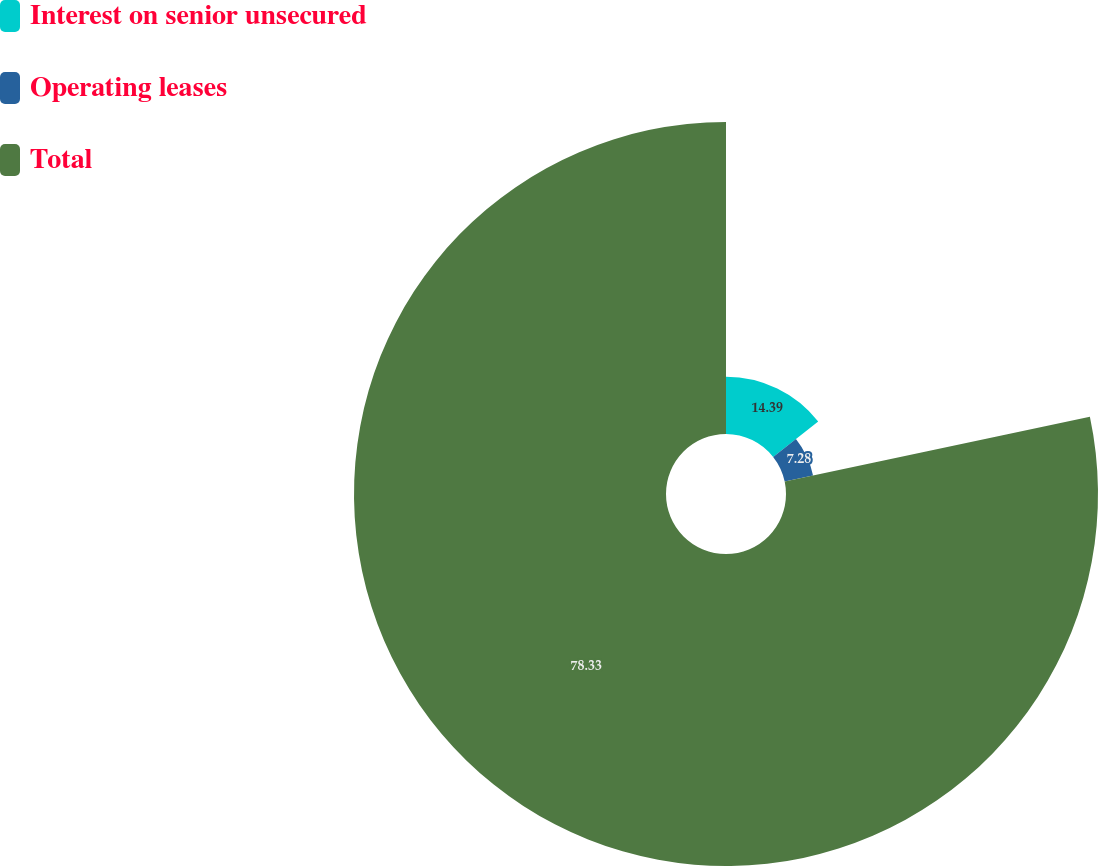Convert chart to OTSL. <chart><loc_0><loc_0><loc_500><loc_500><pie_chart><fcel>Interest on senior unsecured<fcel>Operating leases<fcel>Total<nl><fcel>14.39%<fcel>7.28%<fcel>78.33%<nl></chart> 